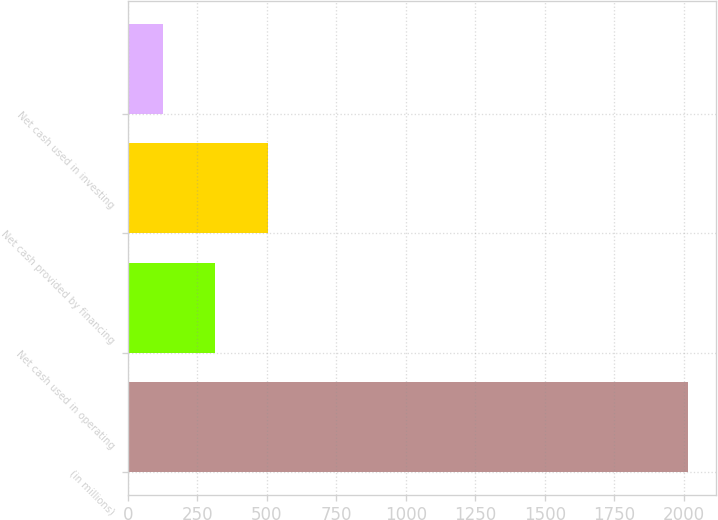Convert chart. <chart><loc_0><loc_0><loc_500><loc_500><bar_chart><fcel>(in millions)<fcel>Net cash used in operating<fcel>Net cash provided by financing<fcel>Net cash used in investing<nl><fcel>2016<fcel>314.1<fcel>503.2<fcel>125<nl></chart> 